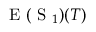Convert formula to latex. <formula><loc_0><loc_0><loc_500><loc_500>E ( S _ { 1 } ) ( T )</formula> 